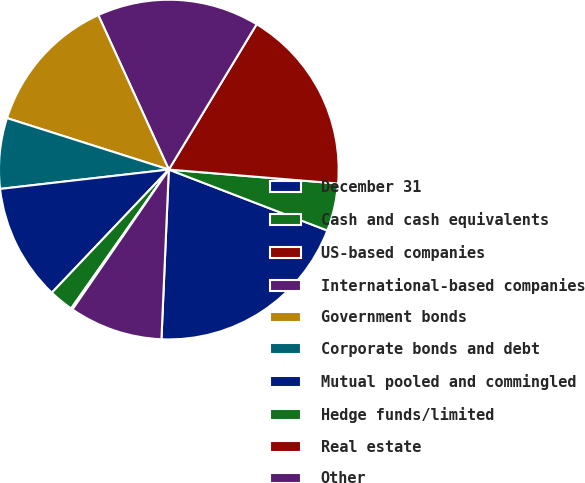Convert chart. <chart><loc_0><loc_0><loc_500><loc_500><pie_chart><fcel>December 31<fcel>Cash and cash equivalents<fcel>US-based companies<fcel>International-based companies<fcel>Government bonds<fcel>Corporate bonds and debt<fcel>Mutual pooled and commingled<fcel>Hedge funds/limited<fcel>Real estate<fcel>Other<nl><fcel>19.85%<fcel>4.53%<fcel>17.66%<fcel>15.47%<fcel>13.28%<fcel>6.72%<fcel>11.09%<fcel>2.34%<fcel>0.15%<fcel>8.91%<nl></chart> 